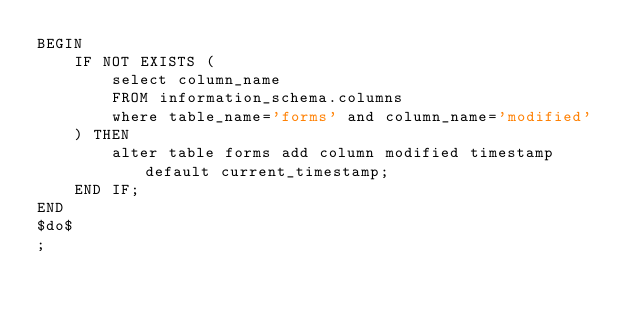Convert code to text. <code><loc_0><loc_0><loc_500><loc_500><_SQL_>BEGIN
    IF NOT EXISTS (
        select column_name 
        FROM information_schema.columns 
        where table_name='forms' and column_name='modified'
    ) THEN
        alter table forms add column modified timestamp default current_timestamp;
    END IF;
END
$do$
;

</code> 